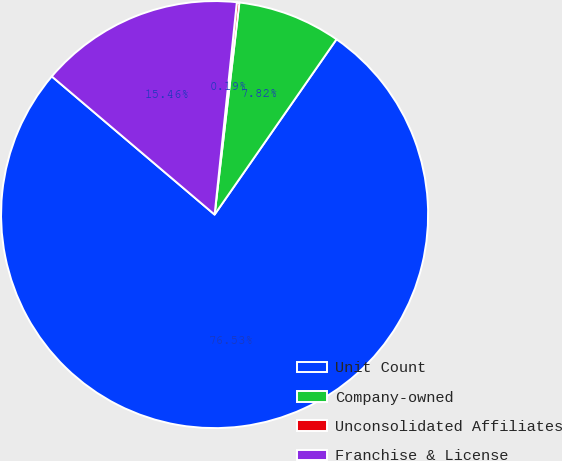Convert chart. <chart><loc_0><loc_0><loc_500><loc_500><pie_chart><fcel>Unit Count<fcel>Company-owned<fcel>Unconsolidated Affiliates<fcel>Franchise & License<nl><fcel>76.53%<fcel>7.82%<fcel>0.19%<fcel>15.46%<nl></chart> 